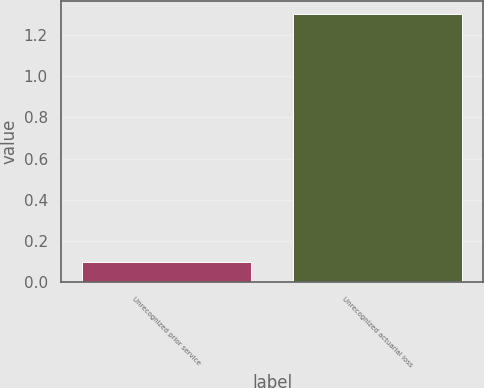<chart> <loc_0><loc_0><loc_500><loc_500><bar_chart><fcel>Unrecognized prior service<fcel>Unrecognized actuarial loss<nl><fcel>0.1<fcel>1.3<nl></chart> 